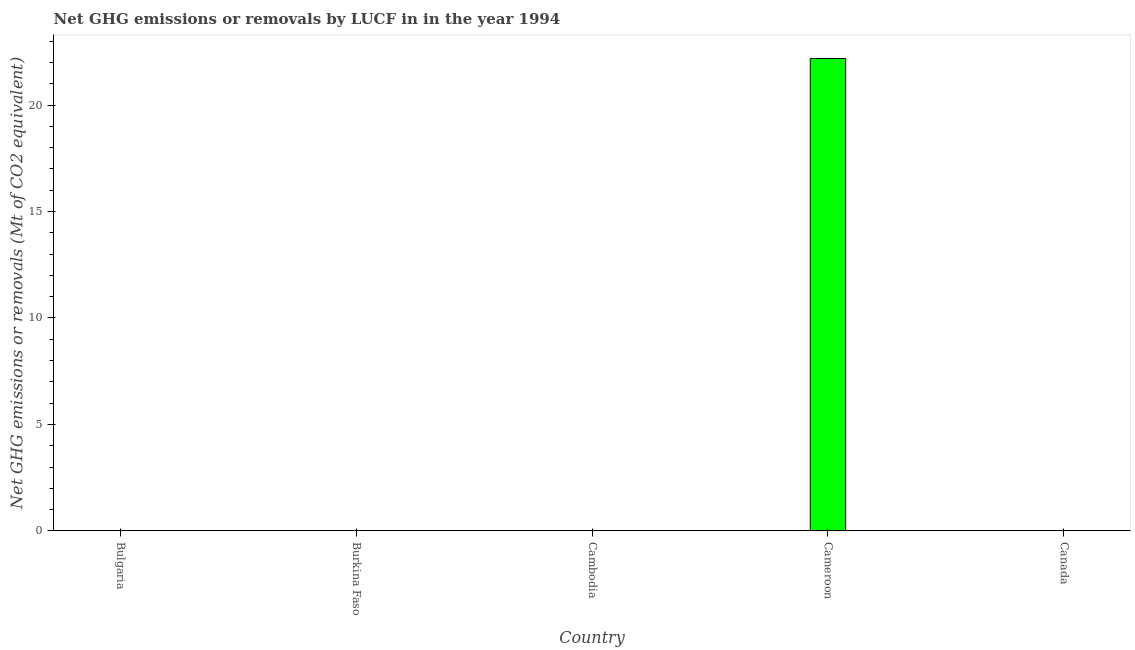What is the title of the graph?
Offer a very short reply. Net GHG emissions or removals by LUCF in in the year 1994. What is the label or title of the X-axis?
Give a very brief answer. Country. What is the label or title of the Y-axis?
Your answer should be very brief. Net GHG emissions or removals (Mt of CO2 equivalent). Across all countries, what is the maximum ghg net emissions or removals?
Ensure brevity in your answer.  22.19. In which country was the ghg net emissions or removals maximum?
Keep it short and to the point. Cameroon. What is the sum of the ghg net emissions or removals?
Keep it short and to the point. 22.19. What is the average ghg net emissions or removals per country?
Ensure brevity in your answer.  4.44. In how many countries, is the ghg net emissions or removals greater than 2 Mt?
Give a very brief answer. 1. What is the difference between the highest and the lowest ghg net emissions or removals?
Offer a terse response. 22.19. How many bars are there?
Ensure brevity in your answer.  1. How many countries are there in the graph?
Provide a succinct answer. 5. Are the values on the major ticks of Y-axis written in scientific E-notation?
Your answer should be compact. No. What is the Net GHG emissions or removals (Mt of CO2 equivalent) in Bulgaria?
Your answer should be very brief. 0. What is the Net GHG emissions or removals (Mt of CO2 equivalent) in Cameroon?
Provide a short and direct response. 22.19. What is the Net GHG emissions or removals (Mt of CO2 equivalent) of Canada?
Provide a succinct answer. 0. 